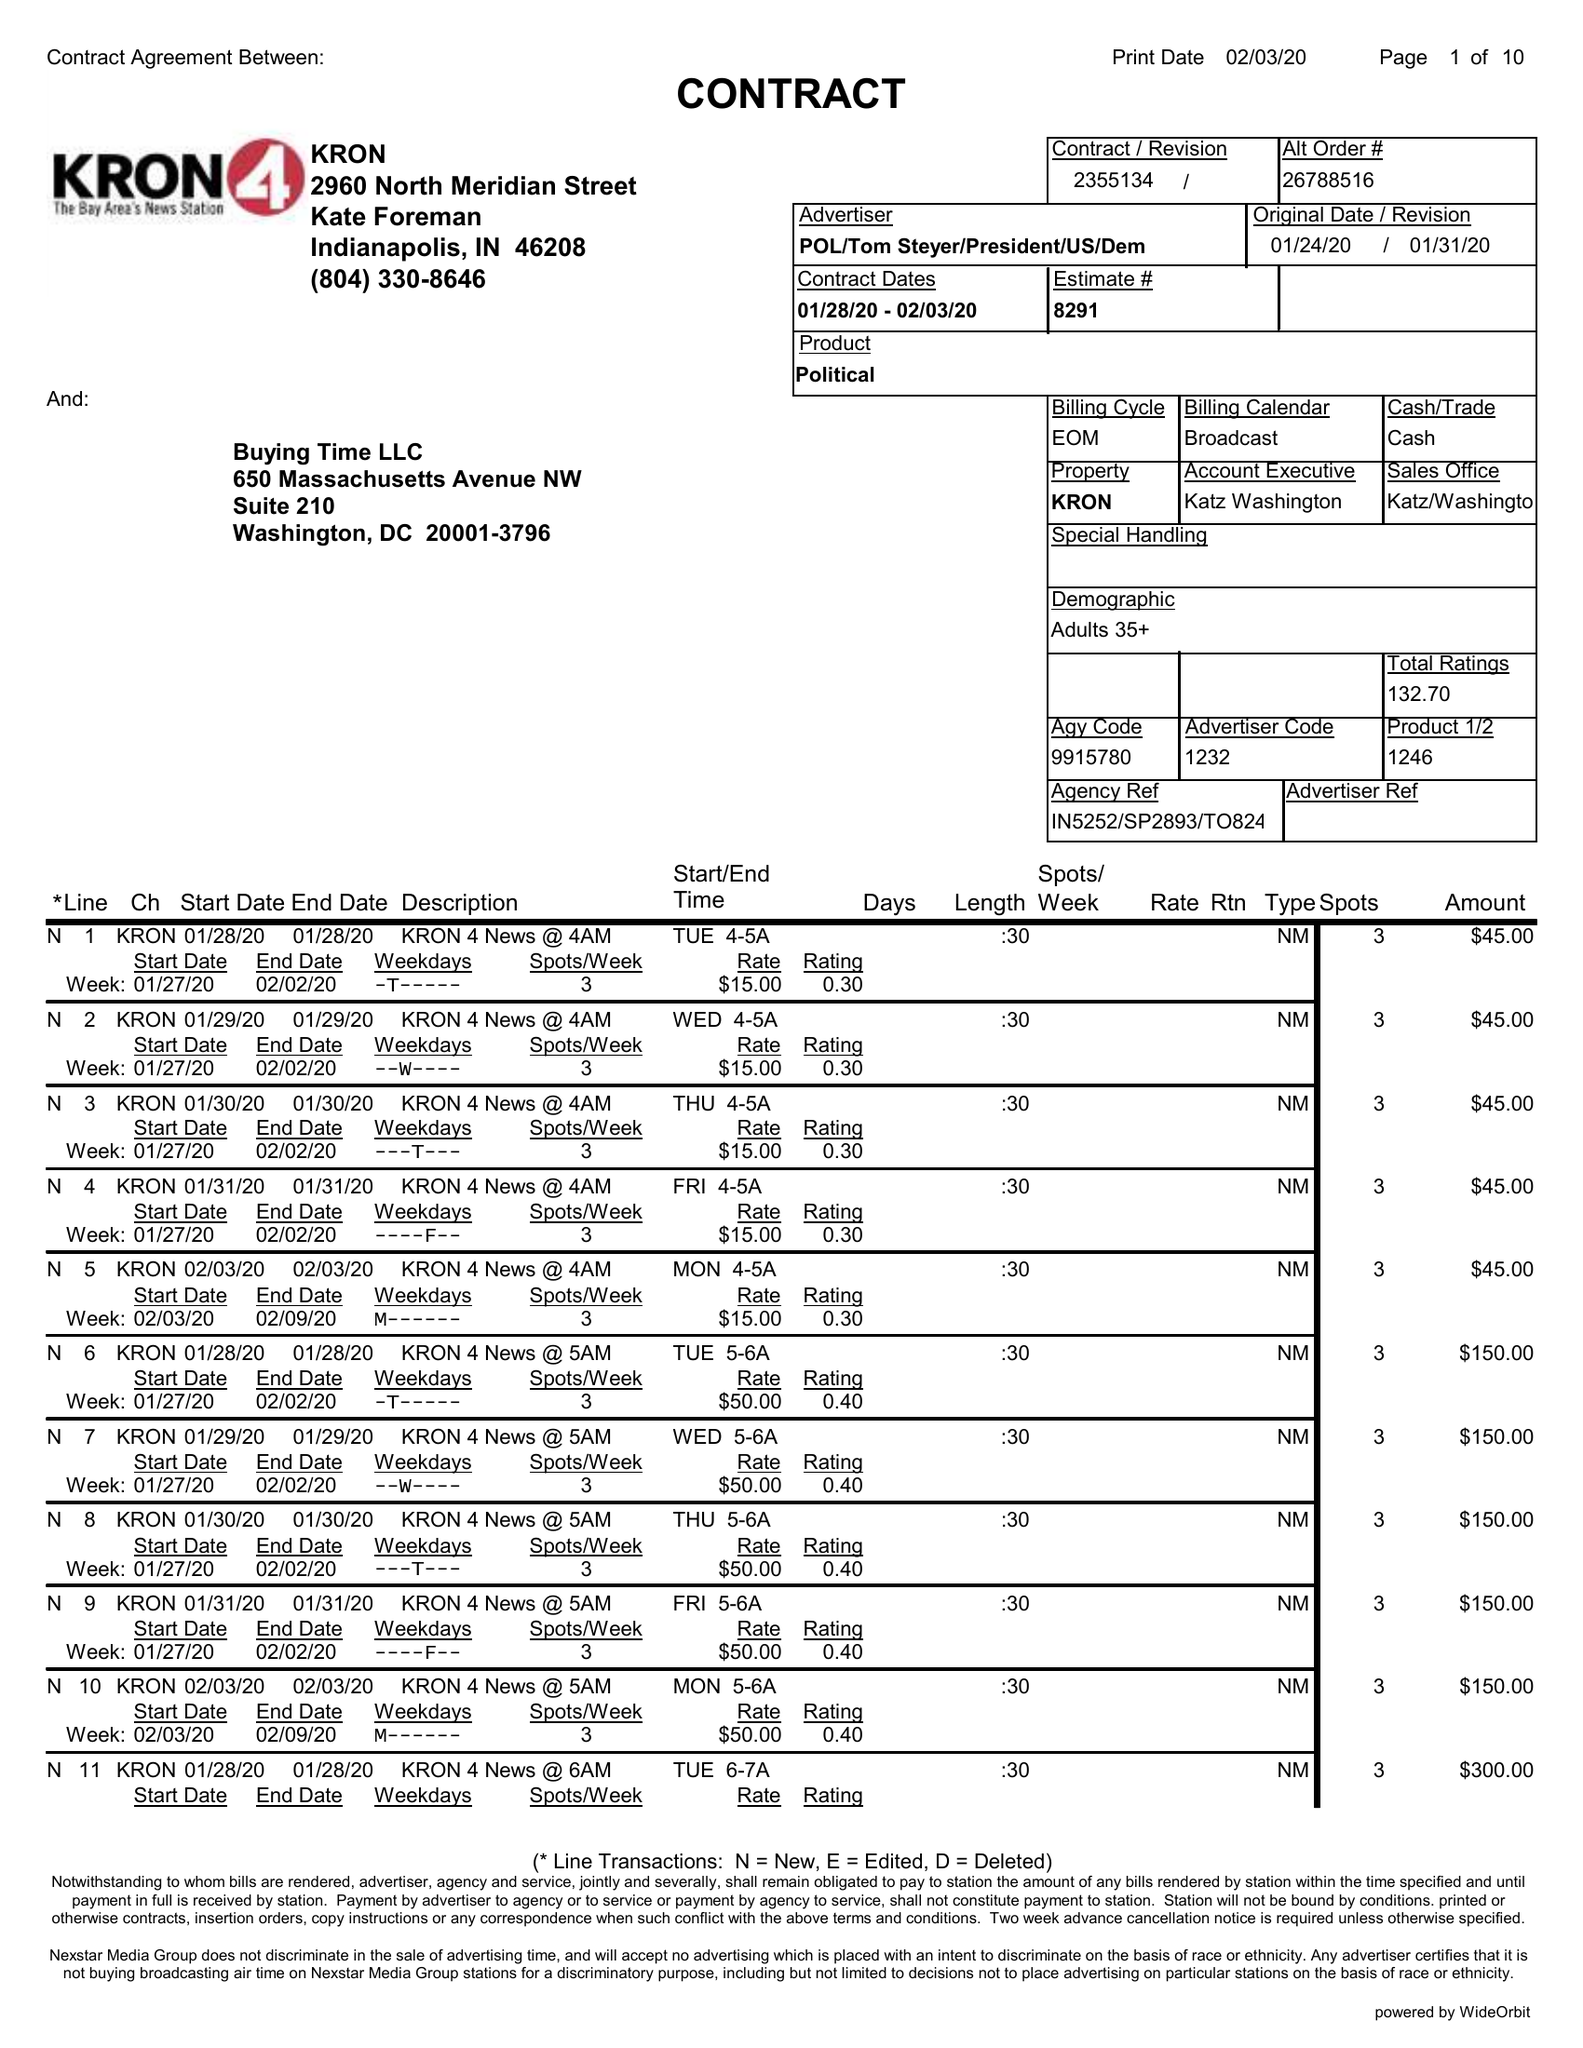What is the value for the advertiser?
Answer the question using a single word or phrase. POL/TOMSTEYER/PRESIDENT/US/DEM 